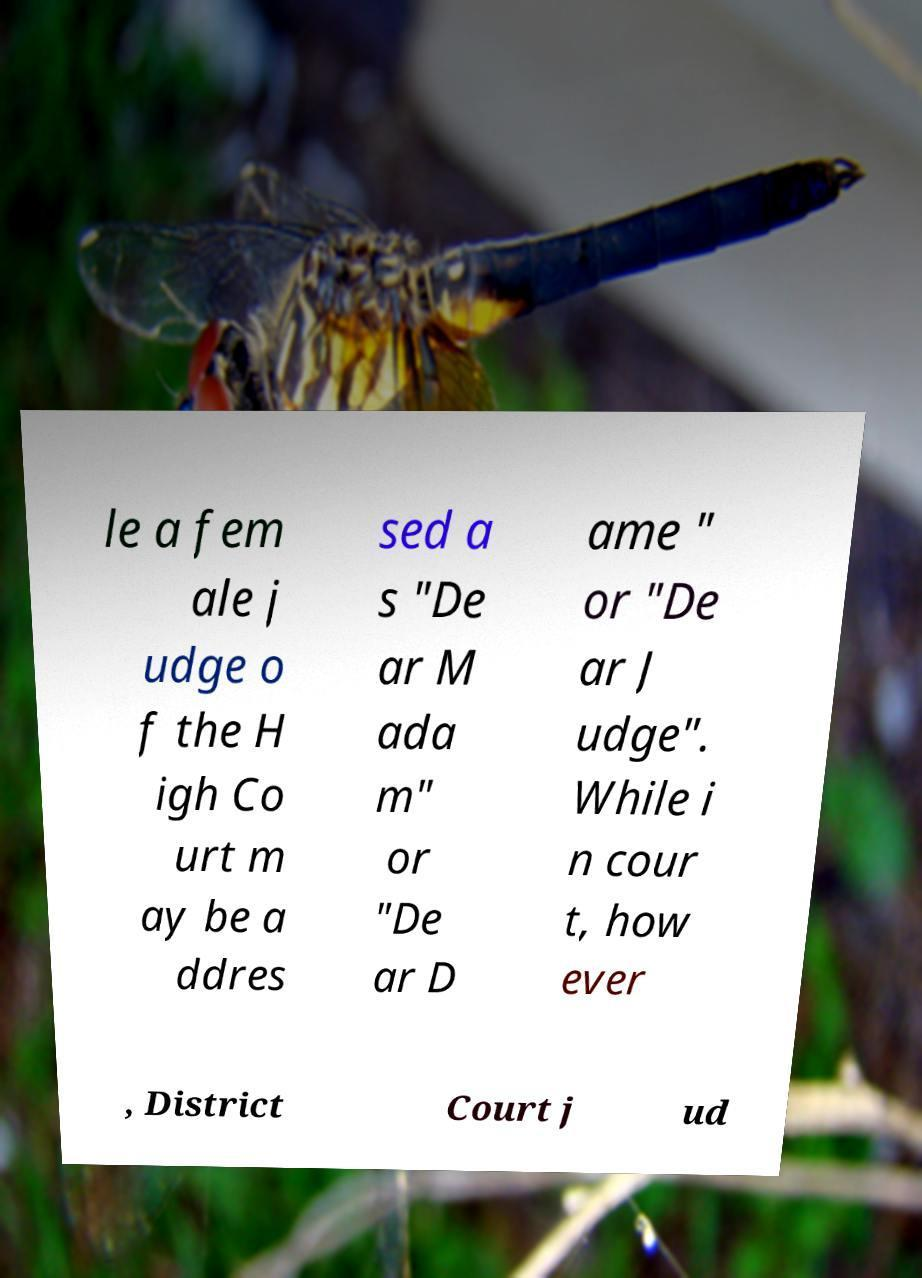Can you accurately transcribe the text from the provided image for me? le a fem ale j udge o f the H igh Co urt m ay be a ddres sed a s "De ar M ada m" or "De ar D ame " or "De ar J udge". While i n cour t, how ever , District Court j ud 